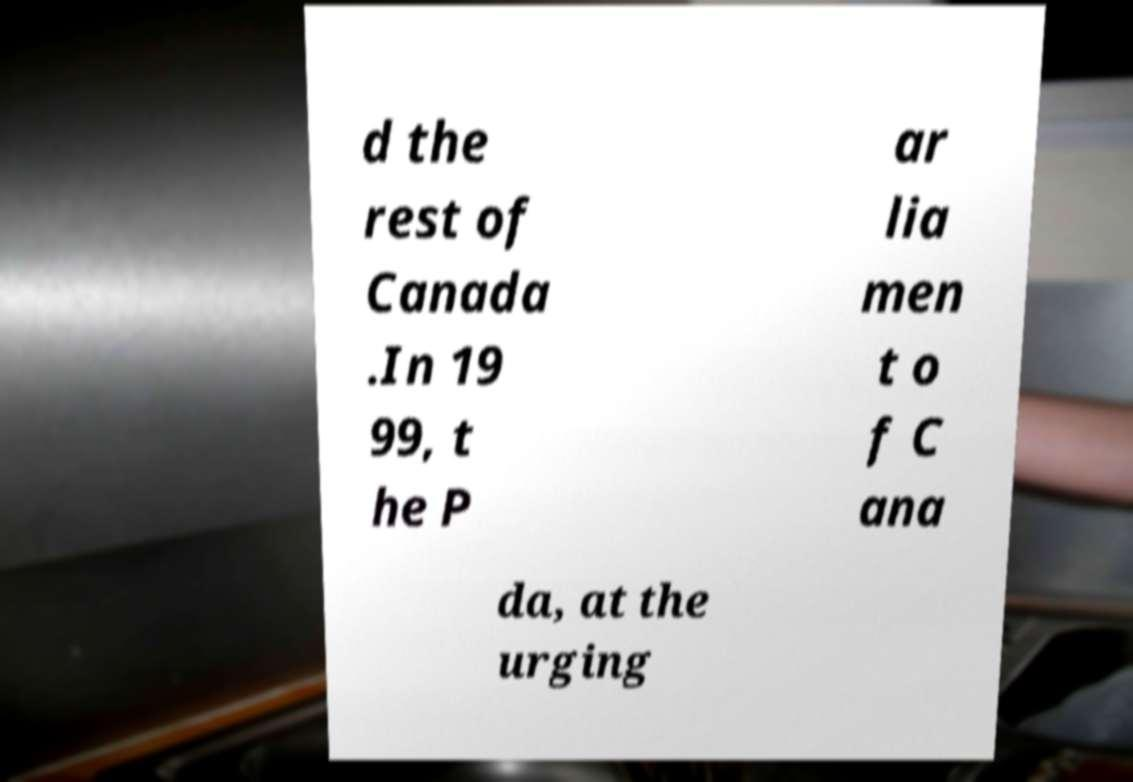What messages or text are displayed in this image? I need them in a readable, typed format. d the rest of Canada .In 19 99, t he P ar lia men t o f C ana da, at the urging 